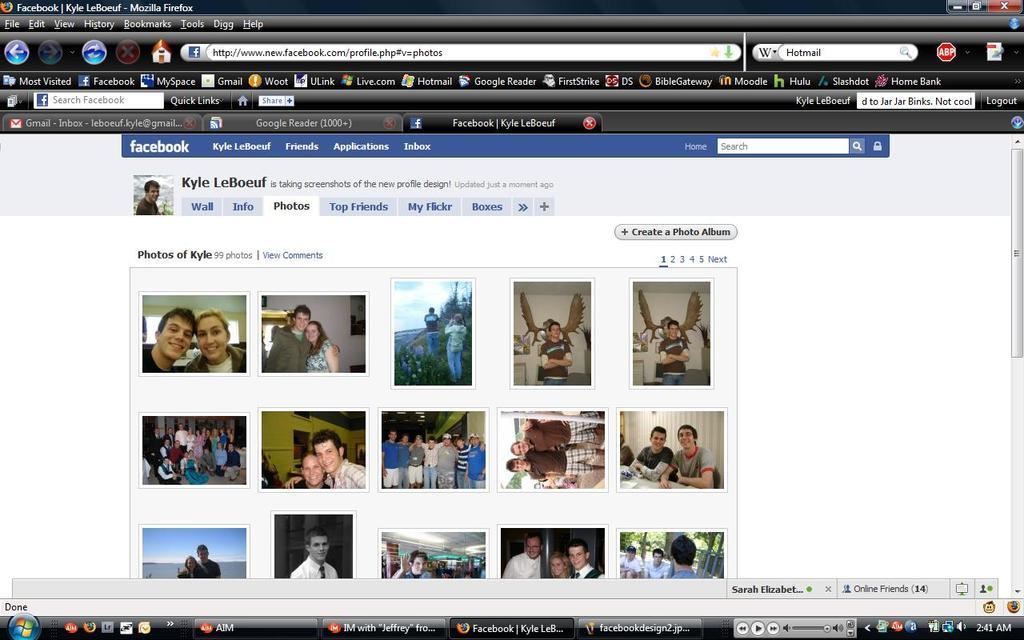What is the main subject of the image? The main subject of the image is a screen. What types of items can be seen on the screen? There are folders, icons, images, numbers, words, and symbols on the screen. What color is the tooth that is visible on the screen? There is no tooth present on the screen; it is a digital image of a screen with folders, icons, images, numbers, words, and symbols. 